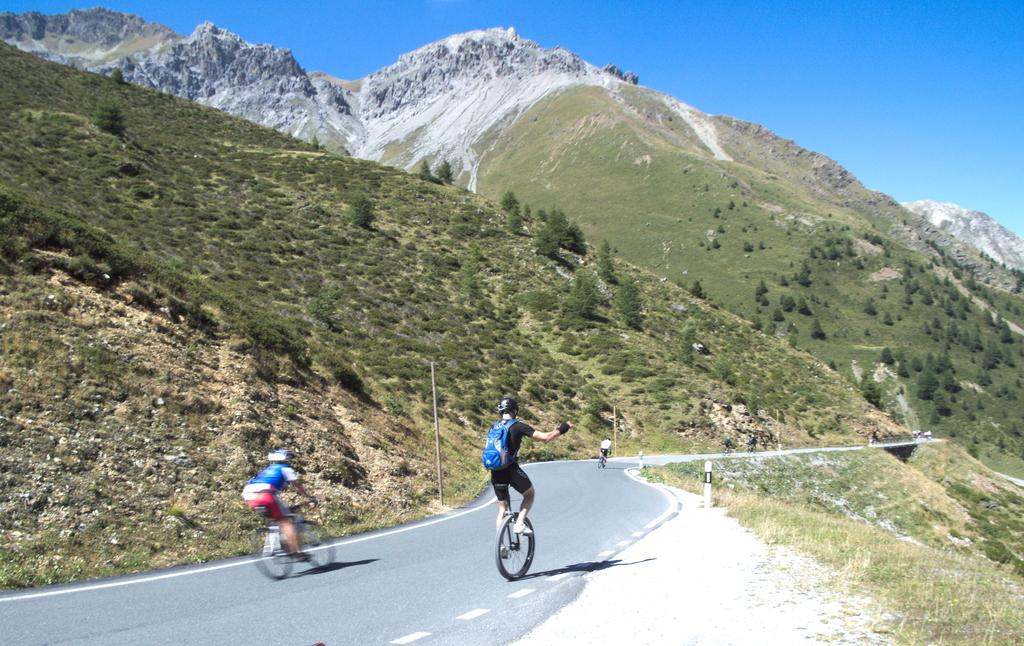What are the people in the image doing? The people in the image are riding bicycles. Where are the bicycles located? The bicycles are on a road. What can be seen in the background of the image? There are hills and the sky visible in the background of the image. What type of vegetation is on the right side of the image? There is grass on the right side of the image. What type of net can be seen on the feet of the people riding bicycles in the image? There is no net present on the feet of the people riding bicycles in the image. 